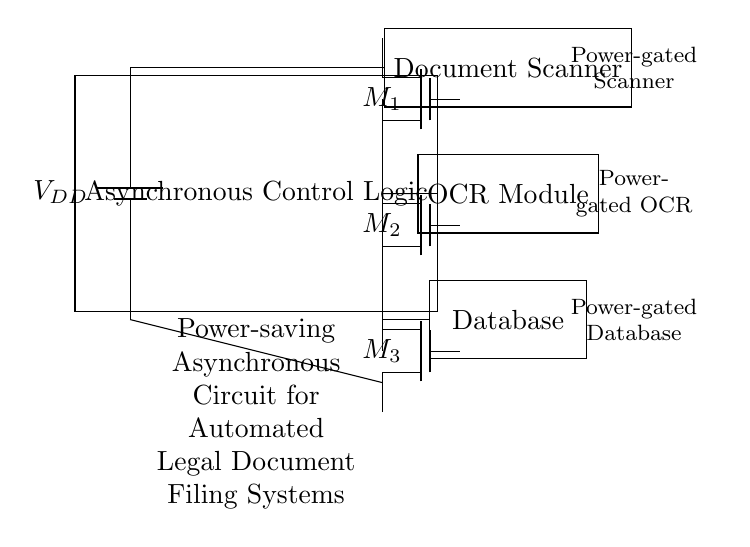What is the power supply voltage? The power supply voltage is indicated by the battery symbol in the circuit diagram. The label next to the battery is VDD, which typically represents the supply voltage in circuits.
Answer: VDD What type of components are used for power gating? The power gating components are indicated by the Tnmos symbols in the circuit. These symbols represent transistors used for power management in the circuit.
Answer: Tnmos Which component is responsible for optical character recognition? The component labeled "OCR Module" in the diagram is responsible for optical character recognition, which is involved in the automated filing process.
Answer: OCR Module How many power gating transistors are present? The circuit diagram shows three Tnmos components, which are used for power gating. You can count the number of Tnmos symbols to determine this.
Answer: 3 What is the primary purpose of this circuit? The label in the diagram specifically states that this is a power-saving asynchronous circuit for automated legal document filing systems, as seen in the large label at the bottom.
Answer: Power-saving asynchronous circuit for automated legal document filing systems What are the outputs of the control logic? The control logic's outputs are connected to the power gating transistors according to the circuit connections shown. Each of the outputs goes to one of the Tnmos devices, indicating they control the power to various components.
Answer: Scanner, OCR Module, Database 